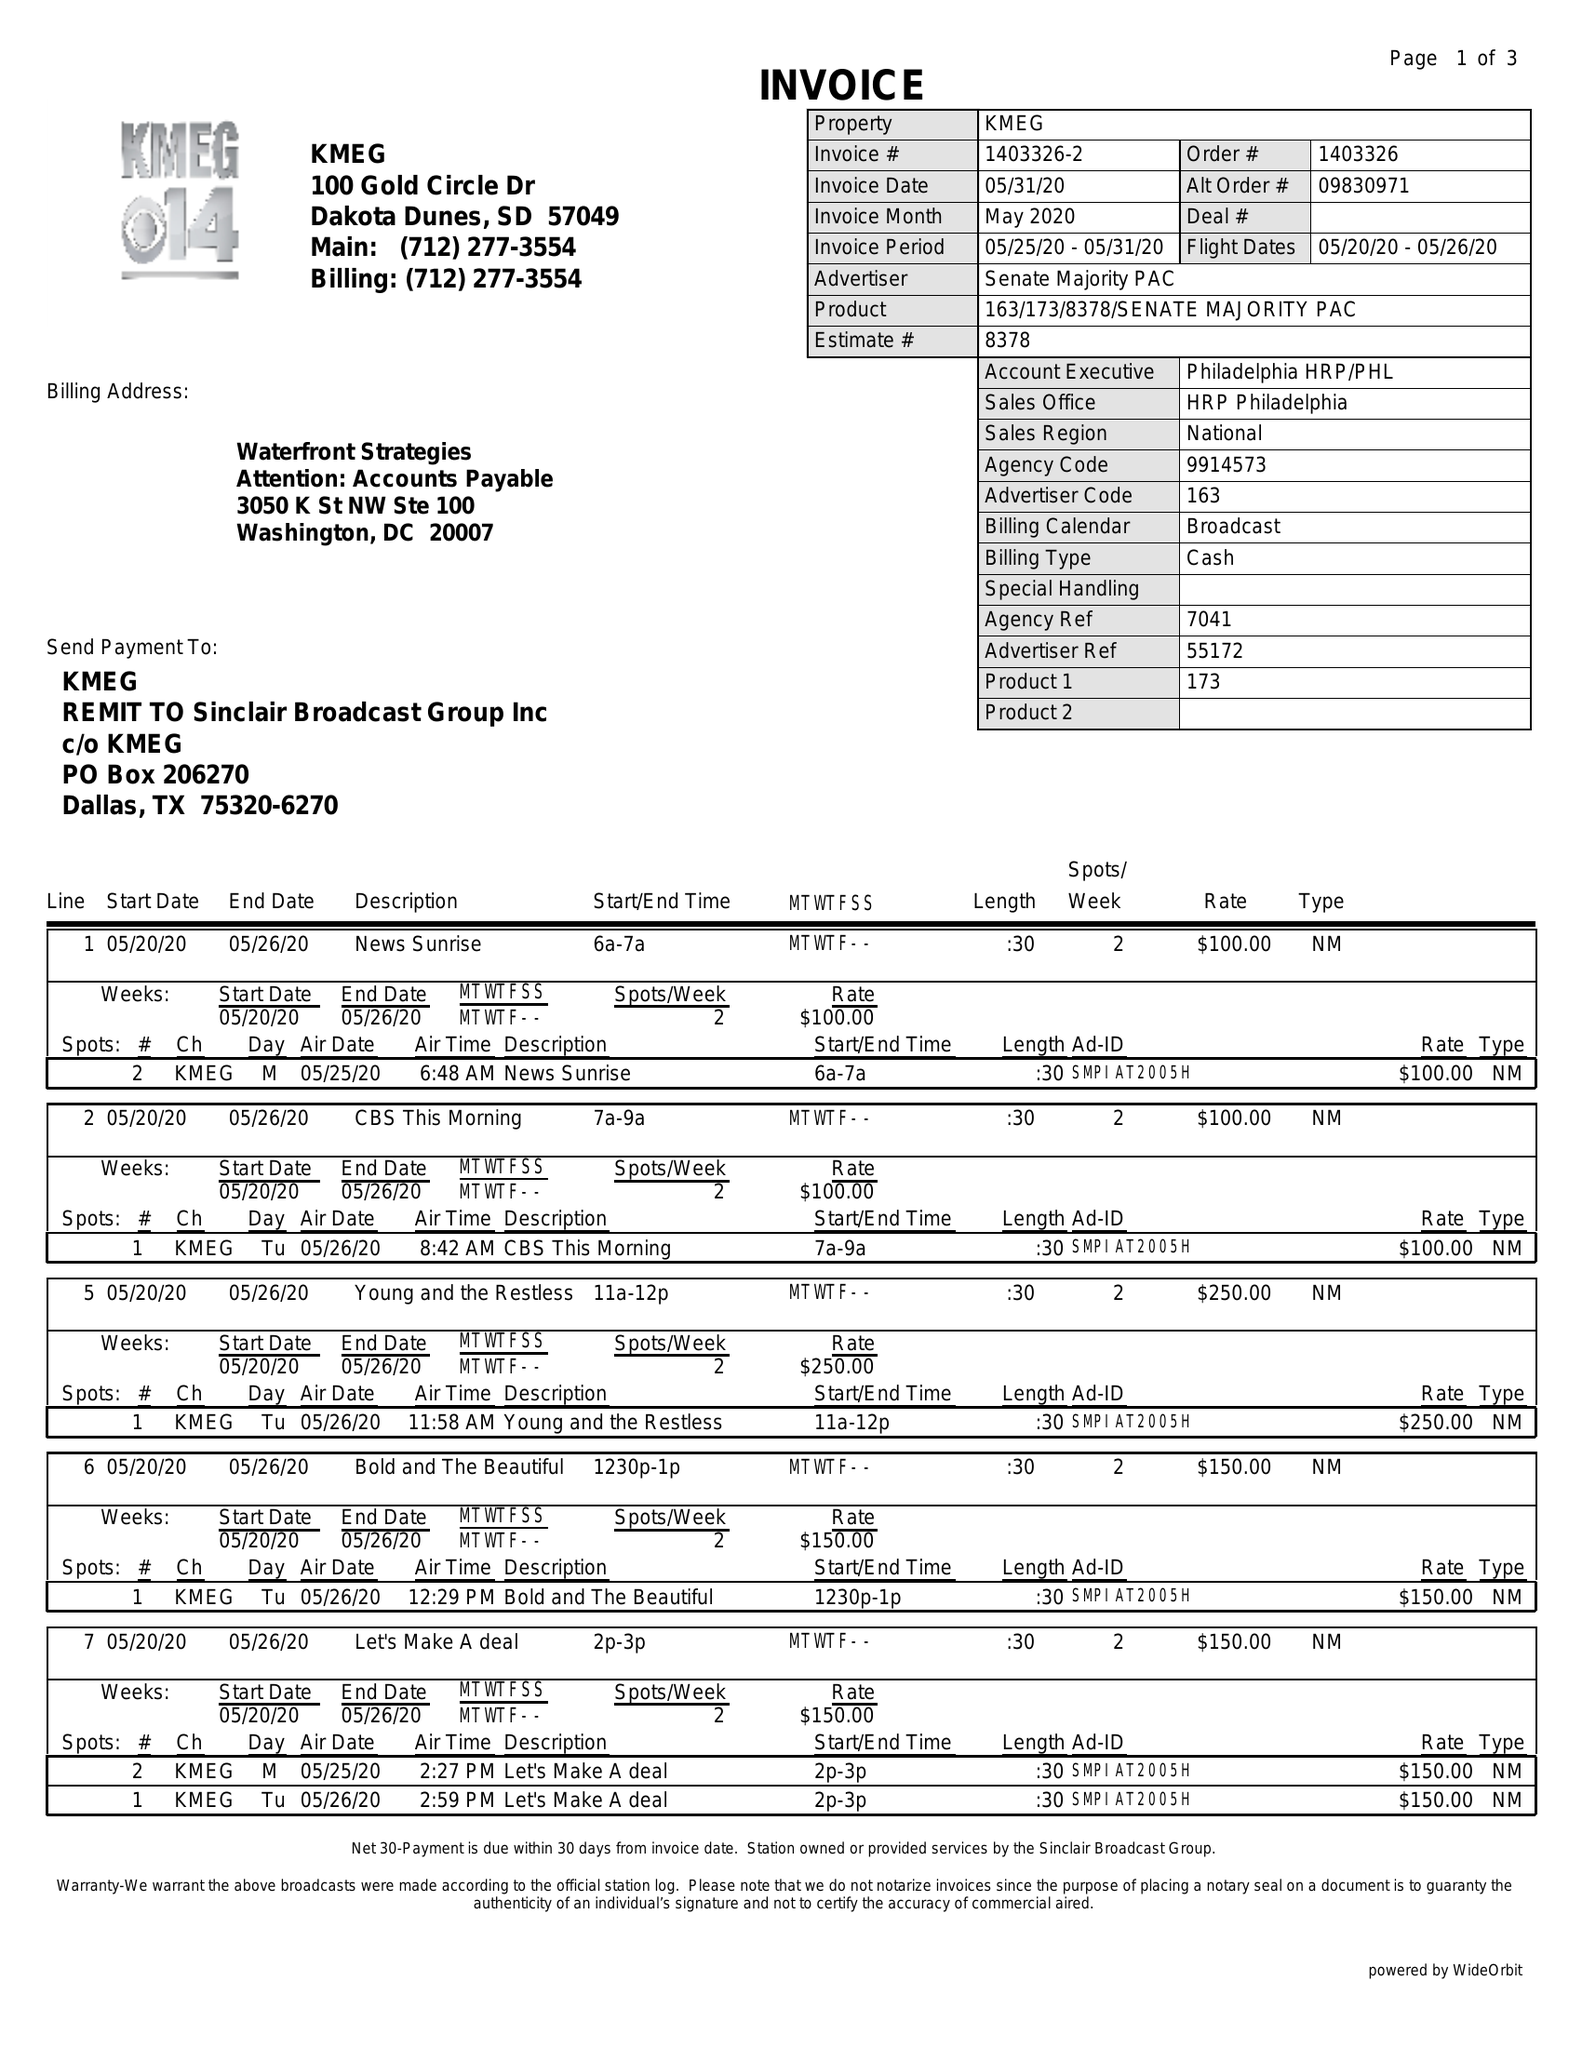What is the value for the flight_from?
Answer the question using a single word or phrase. 05/20/20 